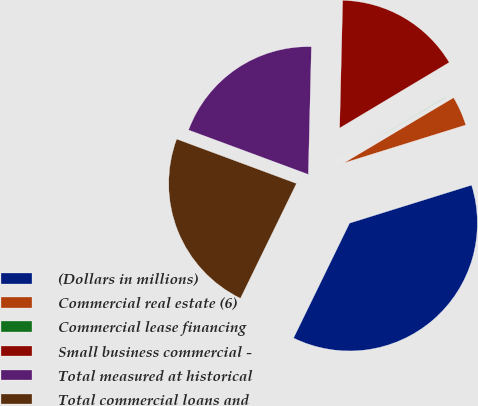Convert chart to OTSL. <chart><loc_0><loc_0><loc_500><loc_500><pie_chart><fcel>(Dollars in millions)<fcel>Commercial real estate (6)<fcel>Commercial lease financing<fcel>Small business commercial -<fcel>Total measured at historical<fcel>Total commercial loans and<nl><fcel>37.03%<fcel>3.74%<fcel>0.04%<fcel>16.03%<fcel>19.73%<fcel>23.43%<nl></chart> 